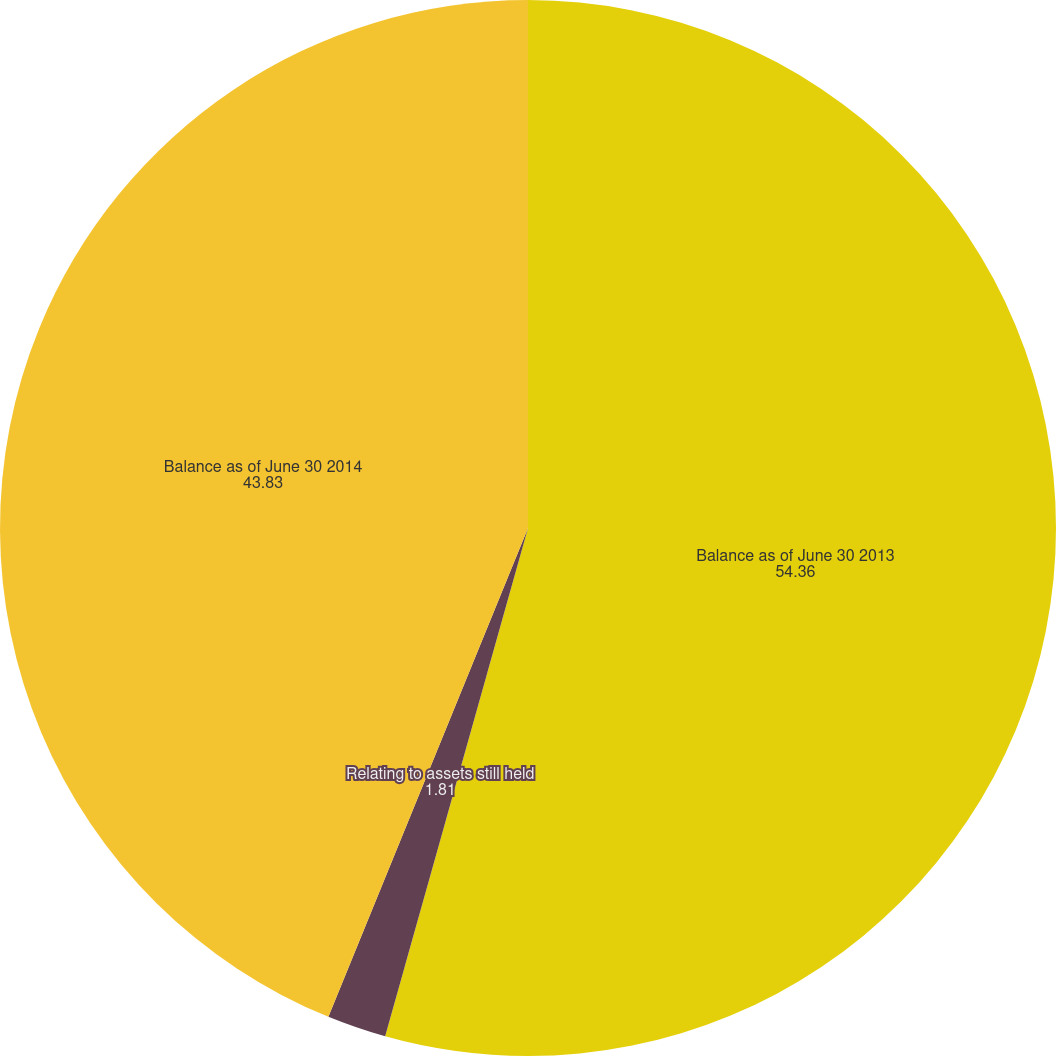Convert chart to OTSL. <chart><loc_0><loc_0><loc_500><loc_500><pie_chart><fcel>Balance as of June 30 2013<fcel>Relating to assets still held<fcel>Balance as of June 30 2014<nl><fcel>54.36%<fcel>1.81%<fcel>43.83%<nl></chart> 